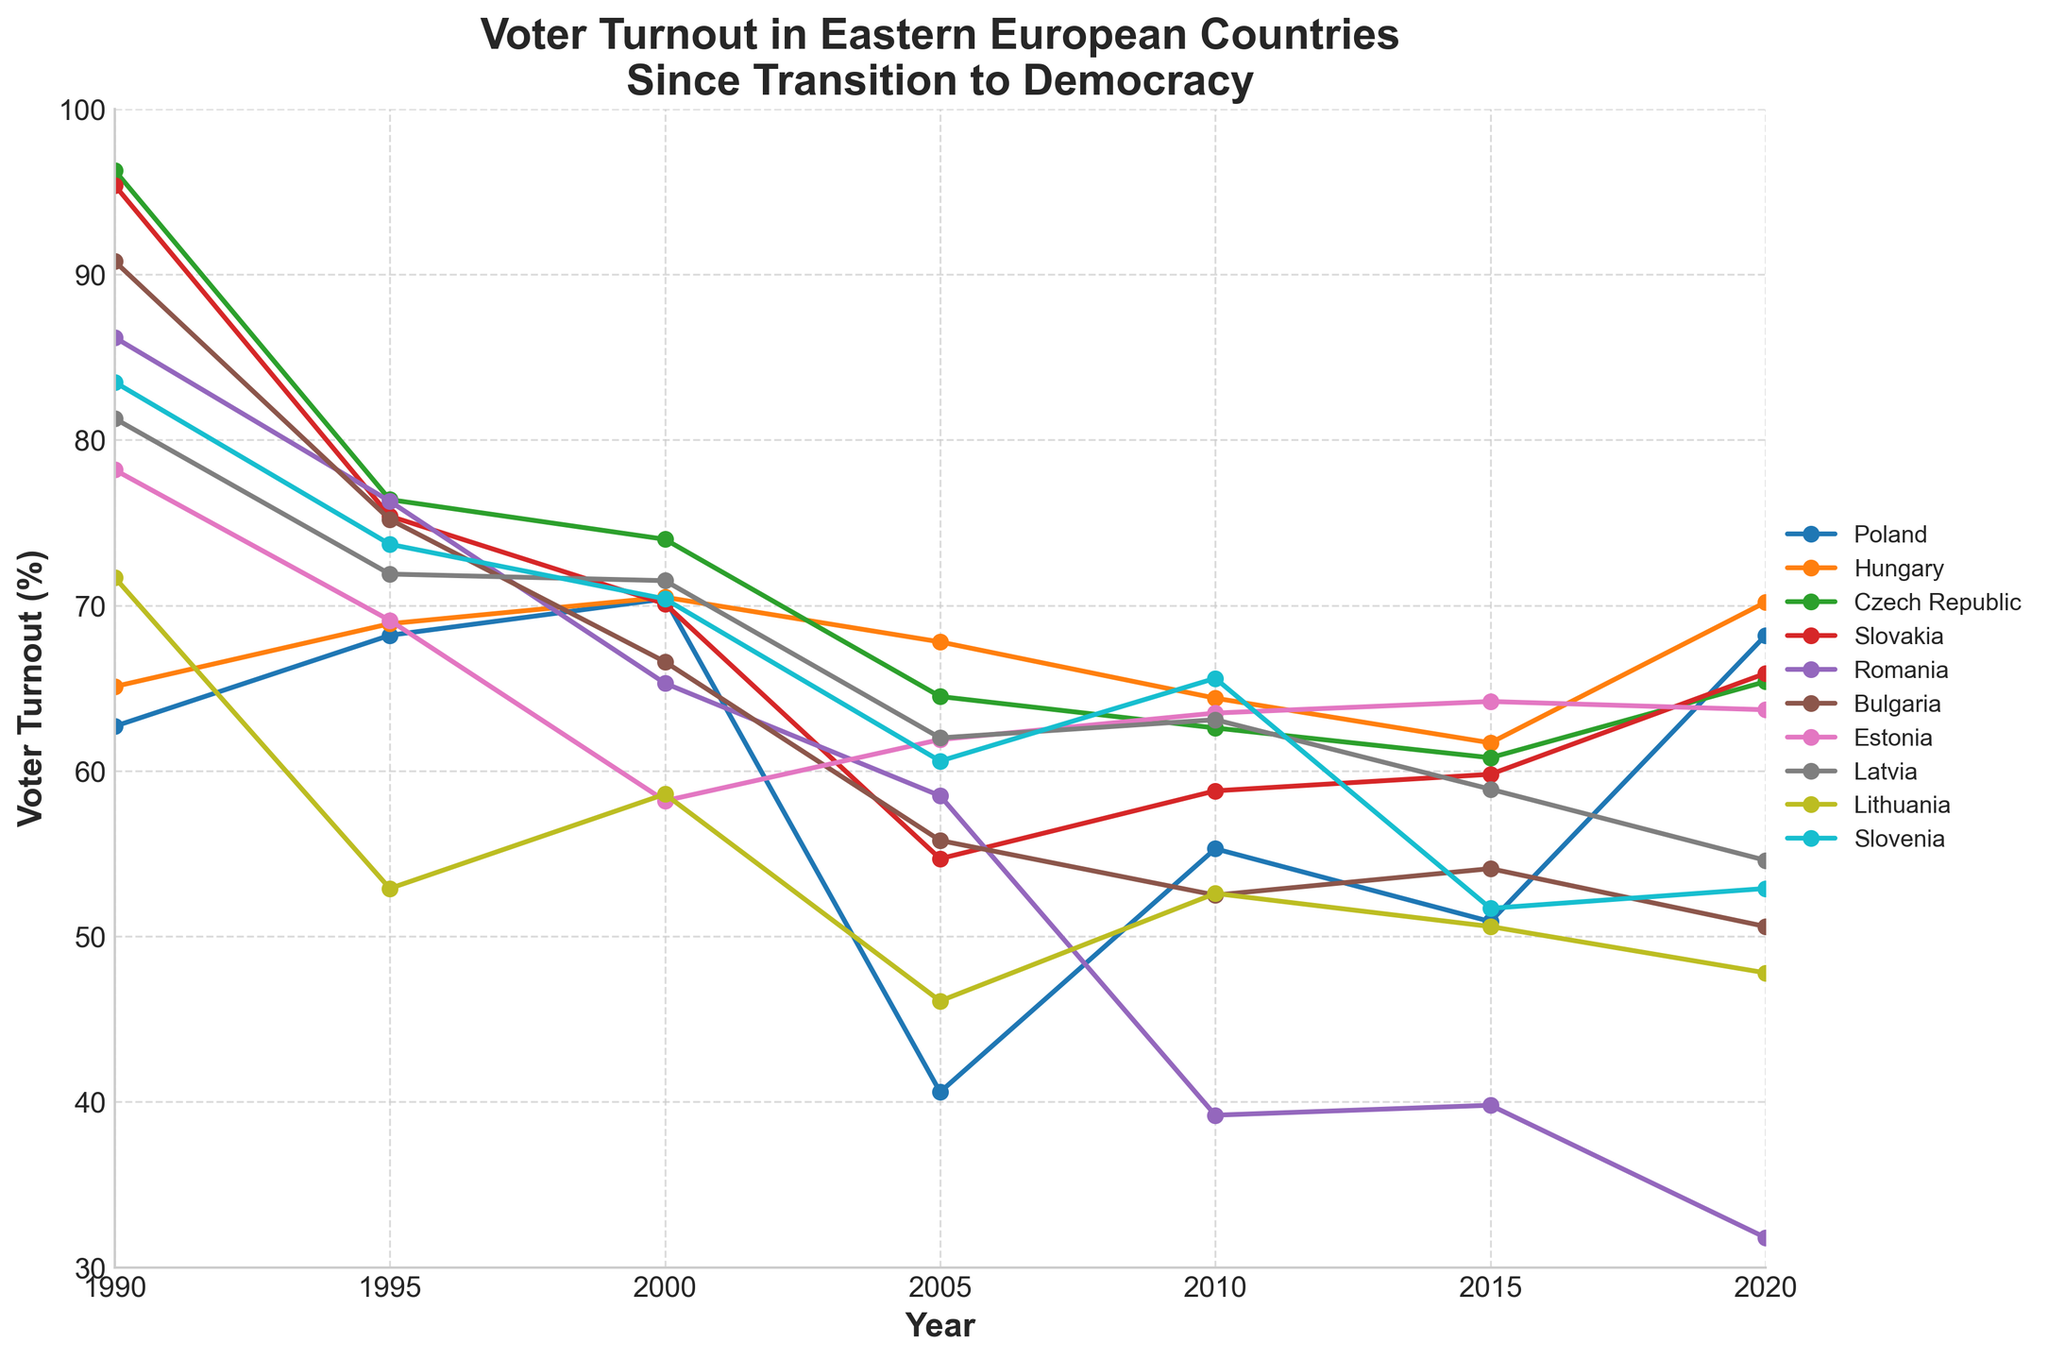What's the trend of voter turnout in Romania from 1990 to 2020? By looking at the plotted line for Romania, you can follow how the voter turnout changes from 1990 to 2020. Observing the points on the line, it starts high in 1990 and then significantly decreases each subsequent year.
Answer: The trend is a significant decrease Which country had the highest voter turnout in 1990? To answer this, look at the plotted lines at the point corresponding to 1990 and compare the heights of the initial points for each country. Czech Republic had the highest point in 1990.
Answer: Czech Republic Between 2000 and 2005, which country experienced the largest drop in voter turnout percentage? Analyze the slope of the lines between 2000 and 2005 for each country. The line with the steepest negative slope represents the largest drop. Romania's line drops significantly in this period.
Answer: Romania Calculate the average voter turnout for Estonia from 1990 to 2020. Add the turnout rates for 1990, 1995, 2000, 2005, 2010, 2015, and 2020 for Estonia and divide by the number of years (7). (78.2 + 69.1 + 58.2 + 61.9 + 63.5 + 64.2 + 63.7) / 7 ≈ 65.5
Answer: 65.5 Which country showed a recovery in voter turnout between 2015 and 2020 after a previous decline? Look for lines that have a downward slope up to 2015 and then an upward slope to 2020. Poland clearly shows this pattern.
Answer: Poland Did any country maintain a consistent voter turnout rate from 1990 to 2020? Determine if any line remains relatively flat across the years without significant ups or downs. None of the countries maintain a consistent rate; all show fluctuations.
Answer: None What is the overall trend in voter turnout for Eastern European countries since their transition to democracy? Observe the majority of the countries' lines collectively from 1990 to 2020, noting that most lines show a downward trend. Despite some recoveries, most countries' voter turnout declines.
Answer: General downward trend Compare the voter turnout of Lithuania and Latvia in 2000. Which country had a higher turnout? Locate the points for Lithuania and Latvia in the year 2000 and compare their heights on the graph. Latvia's point is higher than Lithuania's.
Answer: Latvia Which country had the lowest voter turnout in 2020? Identify and compare the points corresponding to 2020 for all countries. The lowest point in 2020 is for Romania.
Answer: Romania 